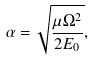<formula> <loc_0><loc_0><loc_500><loc_500>\alpha = \sqrt { \frac { \mu \Omega ^ { 2 } } { 2 E _ { 0 } } } ,</formula> 